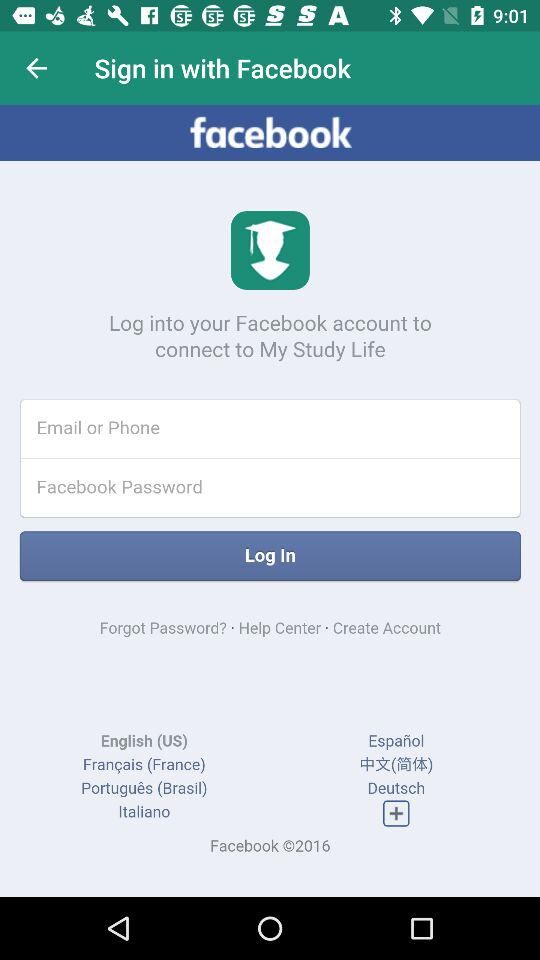What application is being used to sign in? The application that is being used to sign in is "Facebook". 